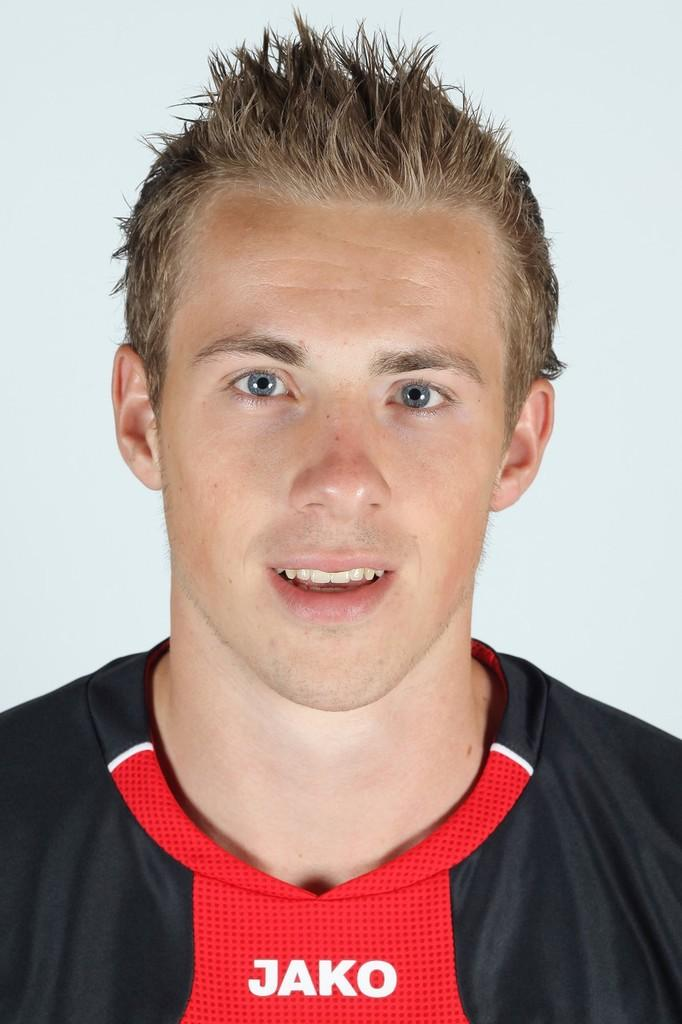<image>
Relay a brief, clear account of the picture shown. A man in a shirt that says Jako smiles for the camera. 